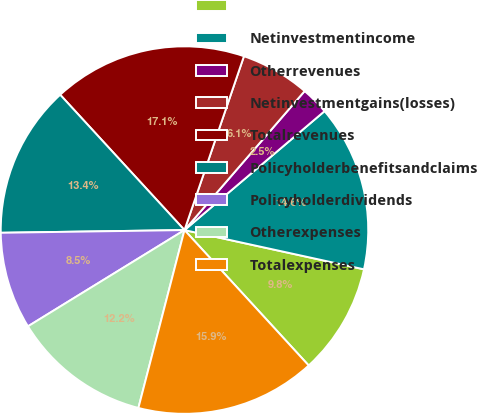Convert chart. <chart><loc_0><loc_0><loc_500><loc_500><pie_chart><ecel><fcel>Netinvestmentincome<fcel>Otherrevenues<fcel>Netinvestmentgains(losses)<fcel>Totalrevenues<fcel>Policyholderbenefitsandclaims<fcel>Policyholderdividends<fcel>Otherexpenses<fcel>Totalexpenses<nl><fcel>9.76%<fcel>14.63%<fcel>2.45%<fcel>6.1%<fcel>17.07%<fcel>13.41%<fcel>8.54%<fcel>12.19%<fcel>15.85%<nl></chart> 